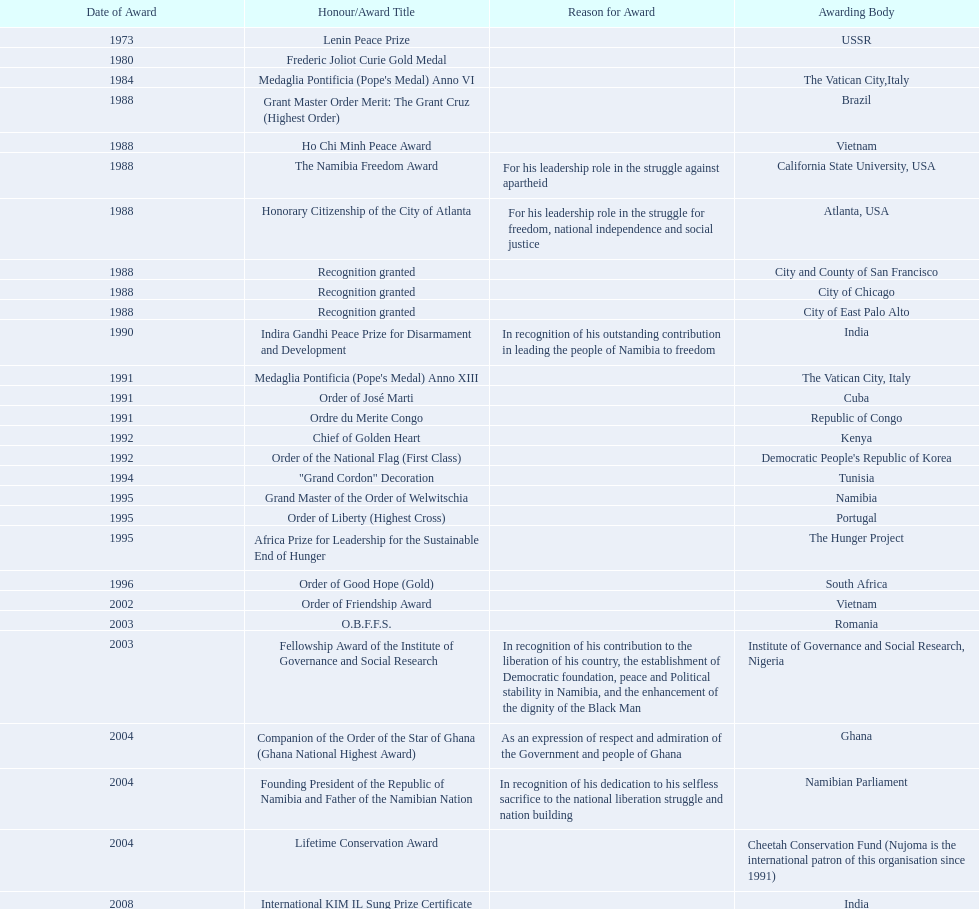What award was won previously just before the medaglia pontificia anno xiii was awarded? Indira Gandhi Peace Prize for Disarmament and Development. 